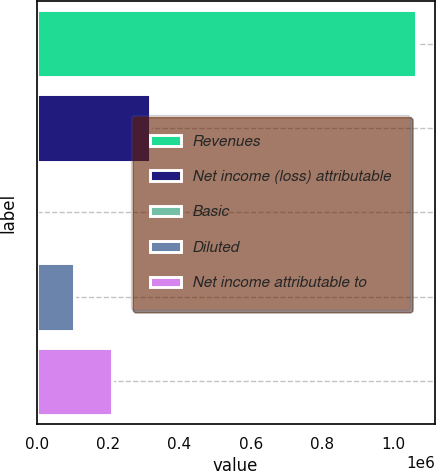Convert chart. <chart><loc_0><loc_0><loc_500><loc_500><bar_chart><fcel>Revenues<fcel>Net income (loss) attributable<fcel>Basic<fcel>Diluted<fcel>Net income attributable to<nl><fcel>1.0623e+06<fcel>318690<fcel>0.86<fcel>106231<fcel>212460<nl></chart> 